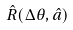Convert formula to latex. <formula><loc_0><loc_0><loc_500><loc_500>\hat { R } ( \Delta \theta , \hat { a } )</formula> 